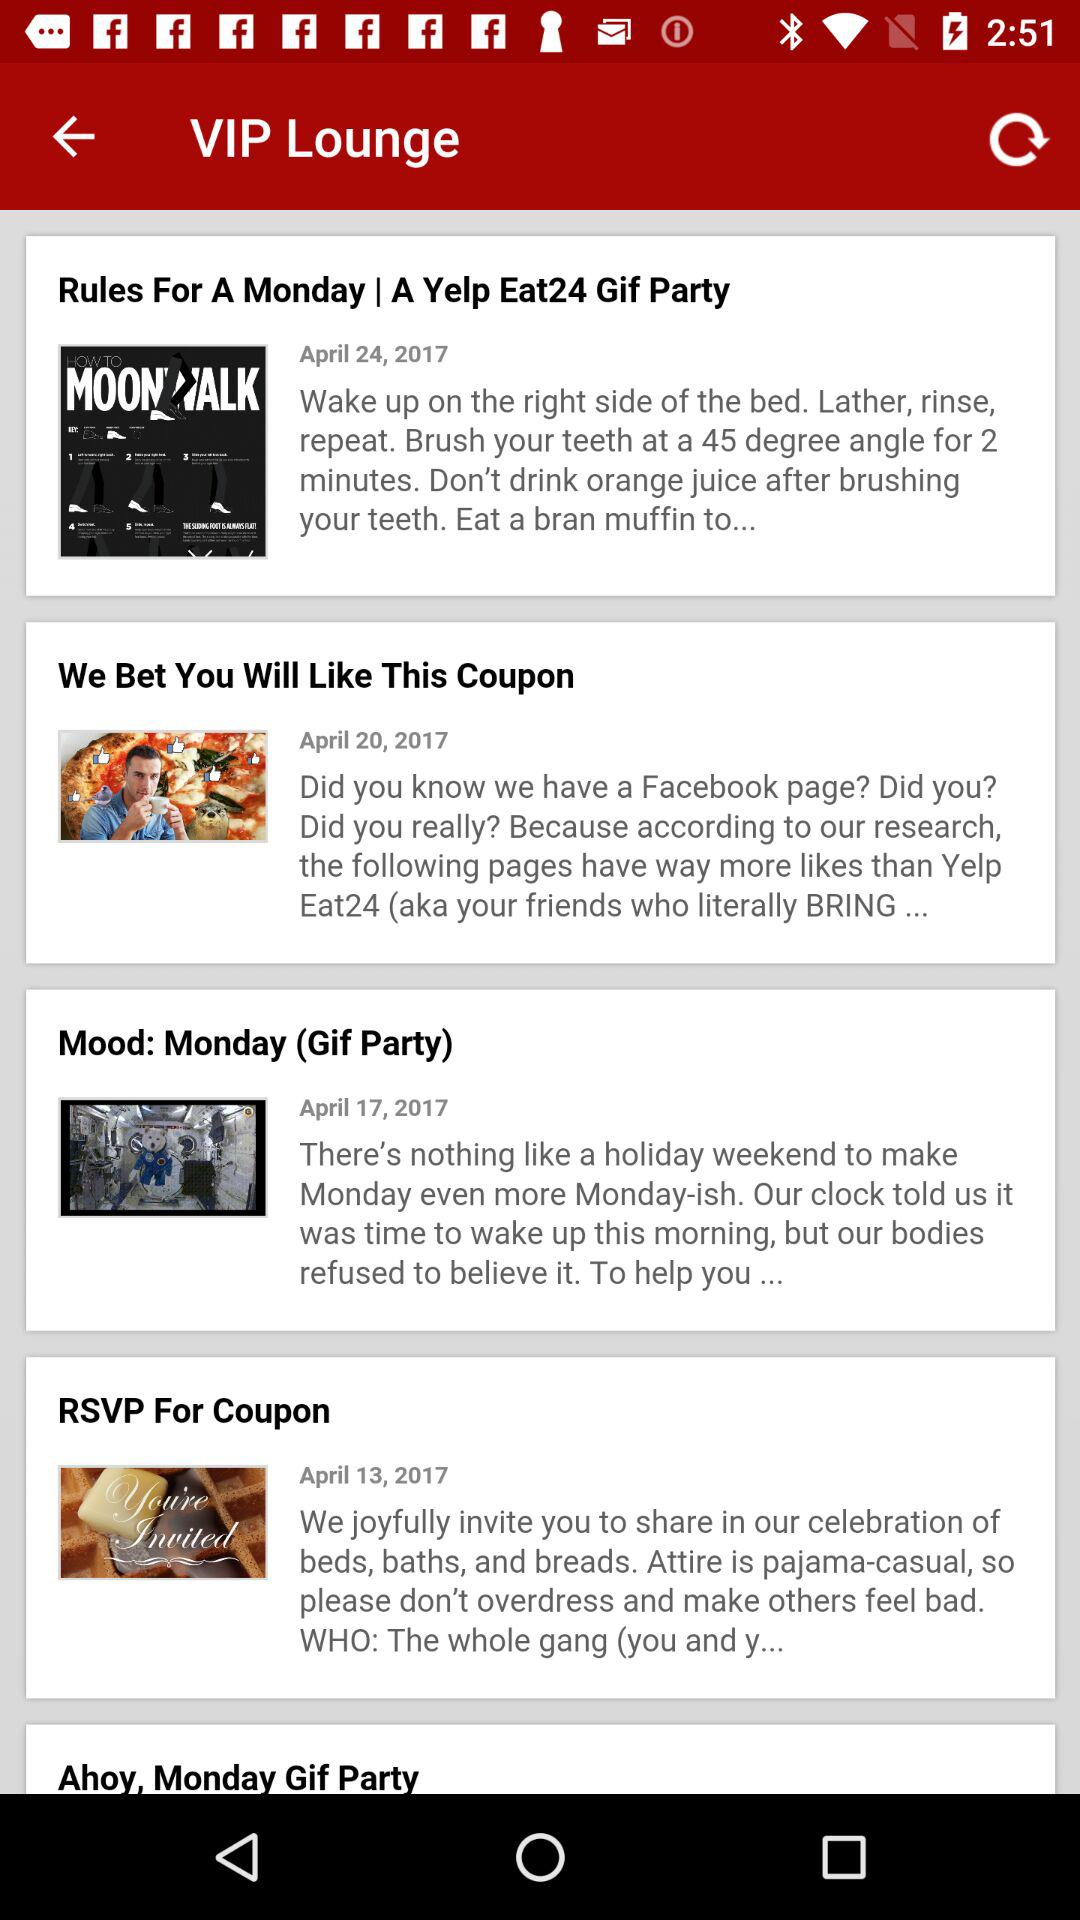What is the given time to brush? The given time is 2 minutes. 